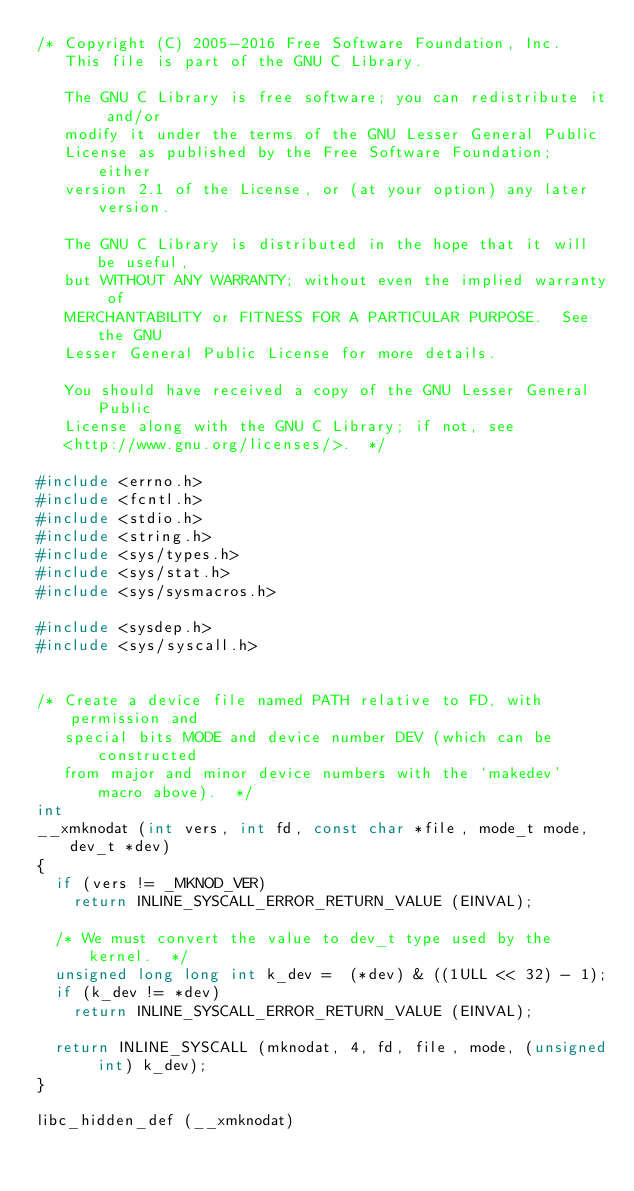Convert code to text. <code><loc_0><loc_0><loc_500><loc_500><_C_>/* Copyright (C) 2005-2016 Free Software Foundation, Inc.
   This file is part of the GNU C Library.

   The GNU C Library is free software; you can redistribute it and/or
   modify it under the terms of the GNU Lesser General Public
   License as published by the Free Software Foundation; either
   version 2.1 of the License, or (at your option) any later version.

   The GNU C Library is distributed in the hope that it will be useful,
   but WITHOUT ANY WARRANTY; without even the implied warranty of
   MERCHANTABILITY or FITNESS FOR A PARTICULAR PURPOSE.  See the GNU
   Lesser General Public License for more details.

   You should have received a copy of the GNU Lesser General Public
   License along with the GNU C Library; if not, see
   <http://www.gnu.org/licenses/>.  */

#include <errno.h>
#include <fcntl.h>
#include <stdio.h>
#include <string.h>
#include <sys/types.h>
#include <sys/stat.h>
#include <sys/sysmacros.h>

#include <sysdep.h>
#include <sys/syscall.h>


/* Create a device file named PATH relative to FD, with permission and
   special bits MODE and device number DEV (which can be constructed
   from major and minor device numbers with the `makedev' macro above).  */
int
__xmknodat (int vers, int fd, const char *file, mode_t mode, dev_t *dev)
{
  if (vers != _MKNOD_VER)
    return INLINE_SYSCALL_ERROR_RETURN_VALUE (EINVAL);

  /* We must convert the value to dev_t type used by the kernel.  */
  unsigned long long int k_dev =  (*dev) & ((1ULL << 32) - 1);
  if (k_dev != *dev)
    return INLINE_SYSCALL_ERROR_RETURN_VALUE (EINVAL);

  return INLINE_SYSCALL (mknodat, 4, fd, file, mode, (unsigned int) k_dev);
}

libc_hidden_def (__xmknodat)
</code> 